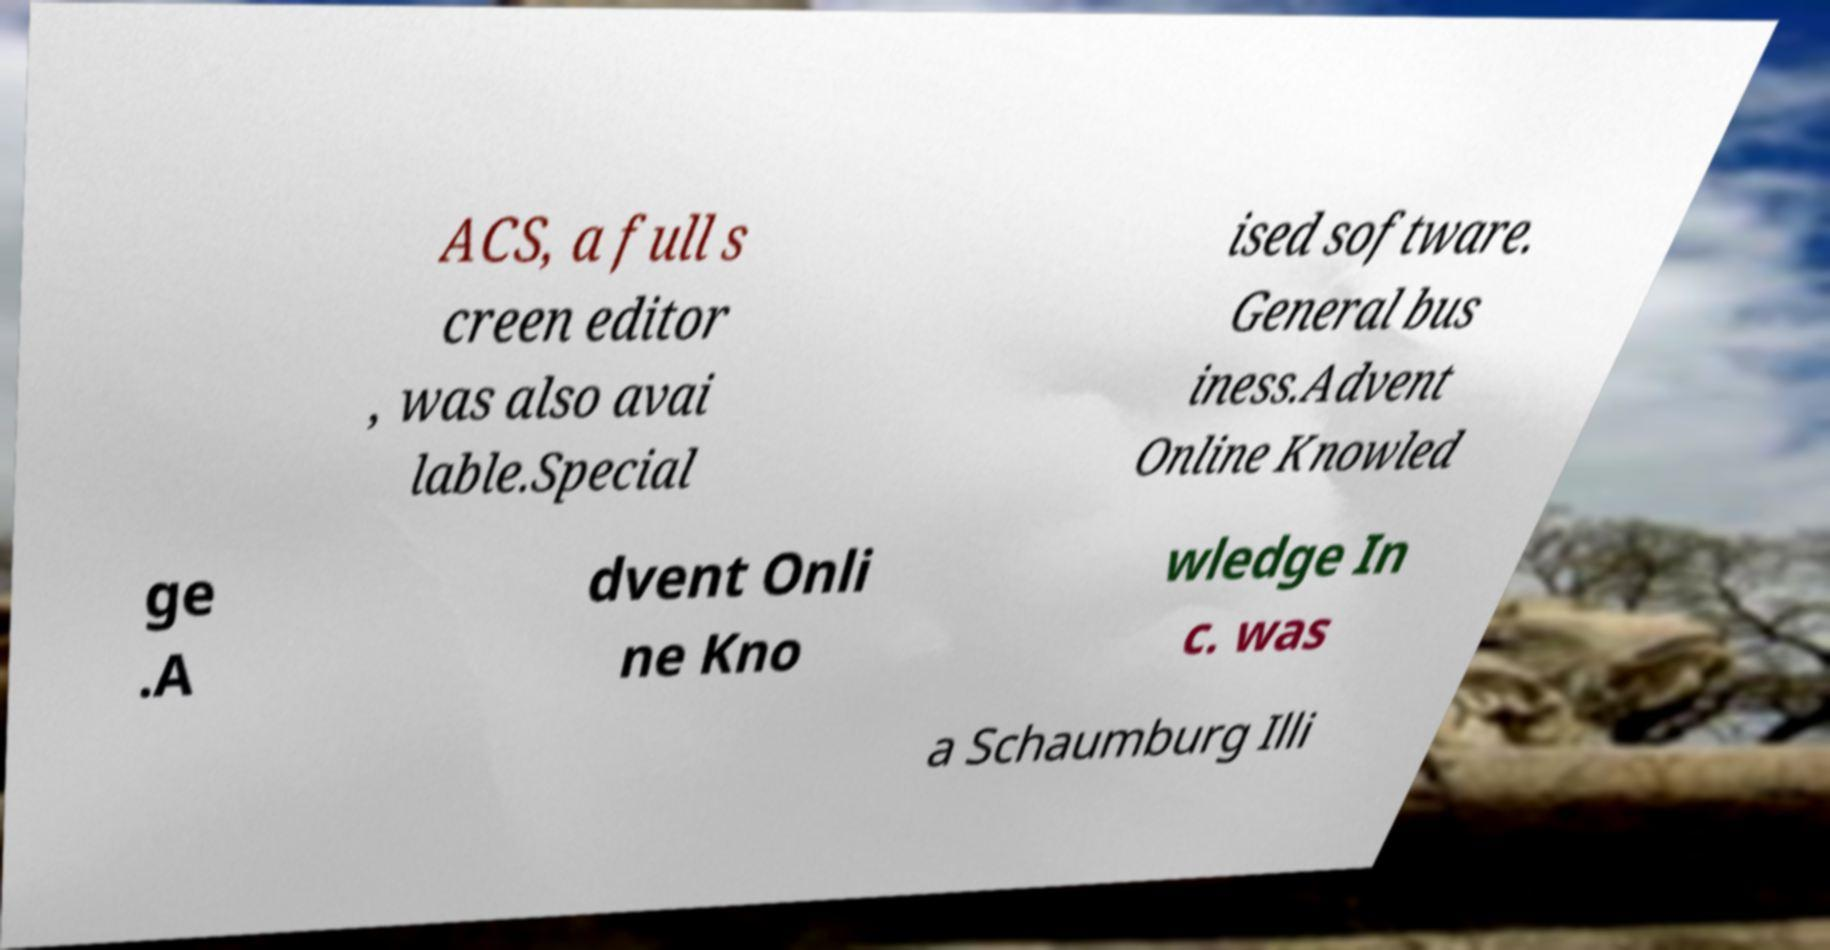Can you accurately transcribe the text from the provided image for me? ACS, a full s creen editor , was also avai lable.Special ised software. General bus iness.Advent Online Knowled ge .A dvent Onli ne Kno wledge In c. was a Schaumburg Illi 